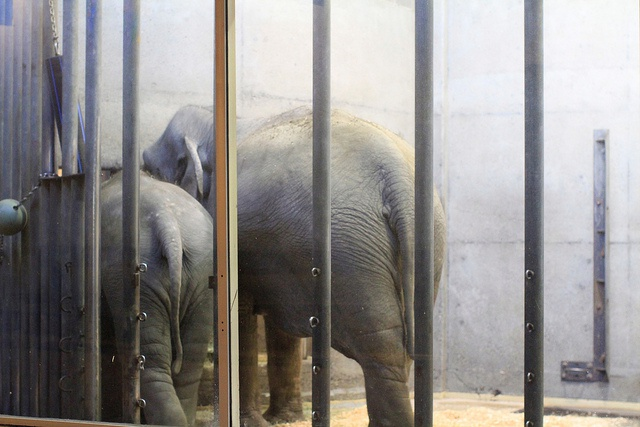Describe the objects in this image and their specific colors. I can see elephant in gray, black, and darkgray tones and elephant in gray, black, and darkgray tones in this image. 